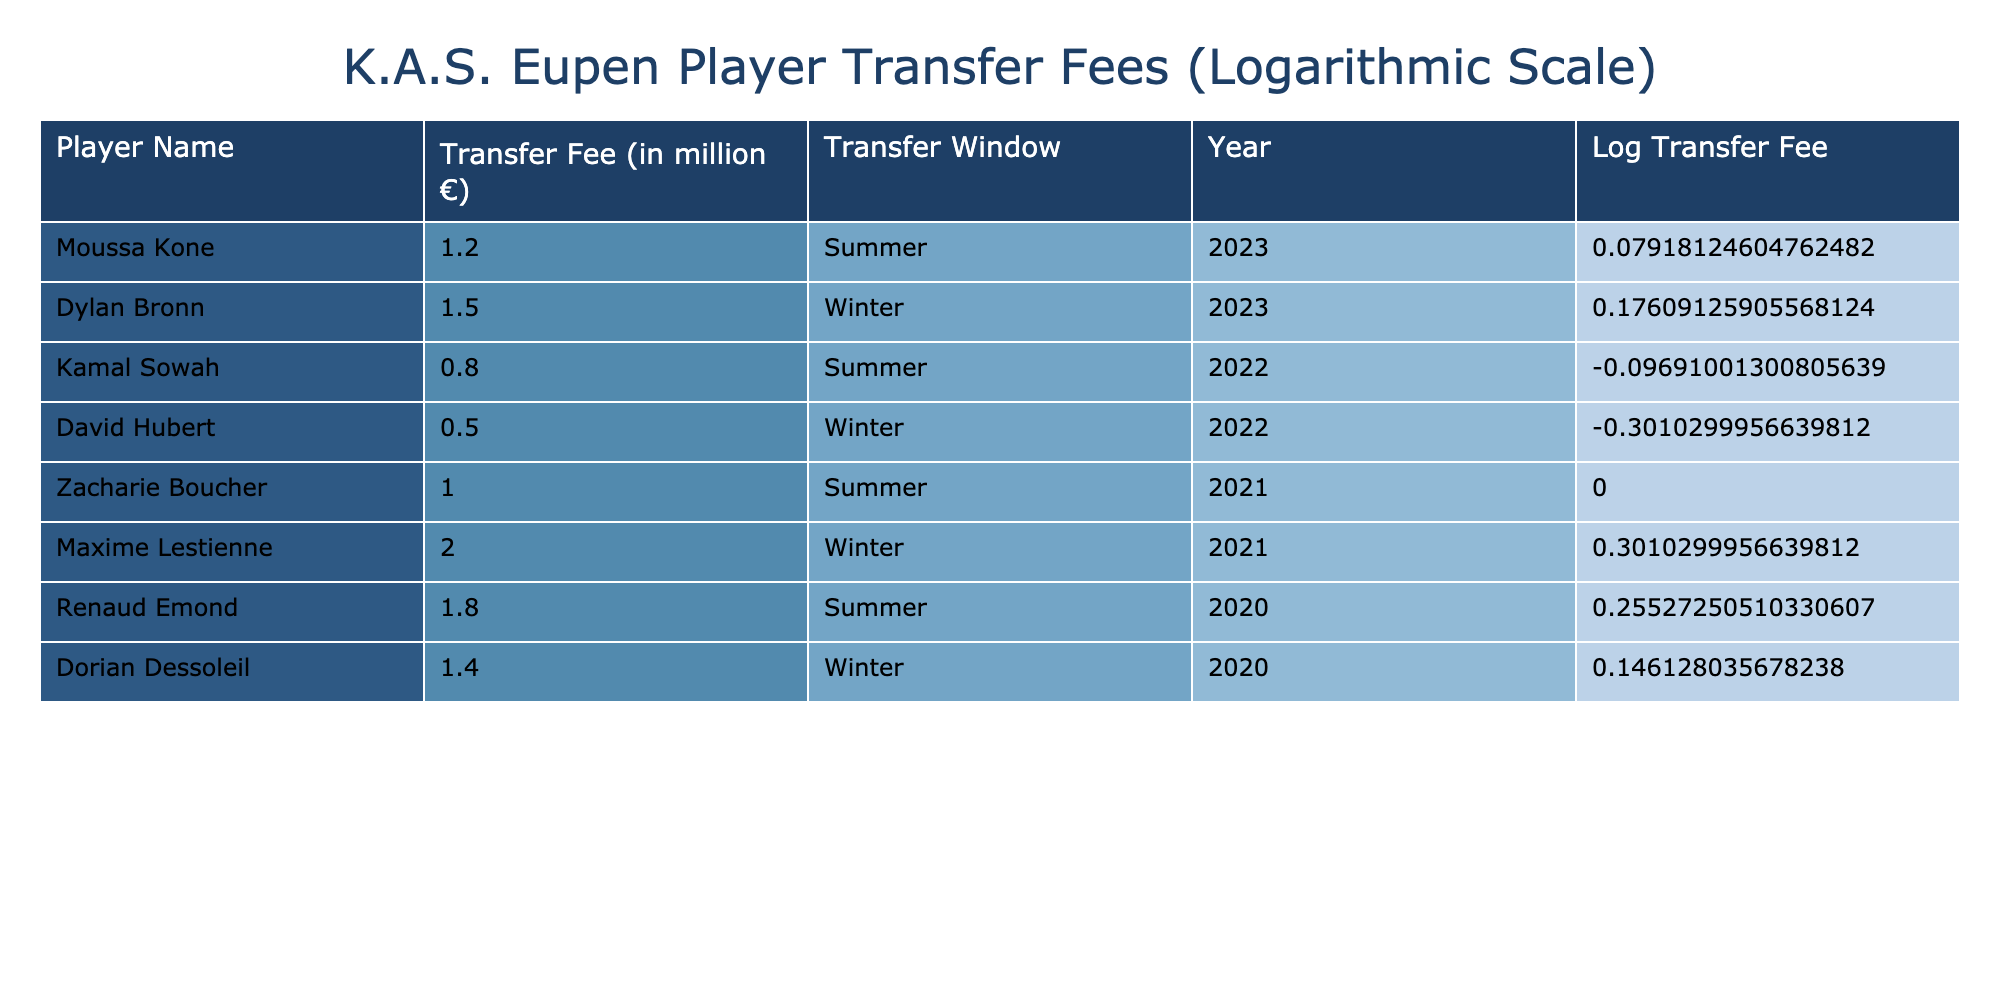What was the highest transfer fee paid by K.A.S. Eupen? The transfer fee listed for 'Maxime Lestienne' is 2.0 million euros, which is the highest among all players in the table.
Answer: 2.0 million € How many players were transferred in the summer of 2022? In the summer of 2022, there was one player transferred, which is 'Kamal Sowah', as seen in the table.
Answer: 1 player What is the total amount spent on transfers in winter transfer windows? The transfer fees for winter transfer windows are 1.5 million euros for 'Dylan Bronn' in winter 2023 and 0.5 million euros for 'David Hubert' in winter 2022. So, the sum is (1.5 + 0.5) = 2.0 million euros.
Answer: 2.0 million € Is it true that 'Renaud Emond' had a higher transfer fee than 'Maxime Lestienne'? 'Renaud Emond' has a transfer fee of 1.8 million euros and 'Maxime Lestienne' has a fee of 2.0 million euros. Therefore, it is false that 'Renaud Emond' had a higher fee.
Answer: No What was the average transfer fee of the players transferred in summer windows? The fees for summer transfers are 1.2 (Kone) + 0.8 (Sowah) + 1.0 (Boucher) + 1.8 (Emond) = 4.8 million euros. There are 4 summer transfers, so the average is 4.8 / 4 = 1.2 million euros.
Answer: 1.2 million € How many players were transferred in the year 2020? The table lists 'Renaud Emond' and 'Dorian Dessoleil' as players transferred in 2020. Thus, there were 2 players transferred that year.
Answer: 2 players What is the log of the transfer fee for 'David Hubert'? The transfer fee for 'David Hubert' is 0.5 million euros. The log transfer fee is log10(0.5) ≈ -0.301 (rounded), which can be calculated directly from its fee.
Answer: Approximately -0.301 Which player was transferred for the largest fee in the last two transfer windows? The last two transfer windows are summer 2023 and winter 2023, and 'Dylan Bronn' has the largest fee of 1.5 million euros in the winter 2023 window. Comparatively, 'Moussa Kone' was transferred for 1.2 million euros in summer 2023.
Answer: 1.5 million € (Dylan Bronn) 